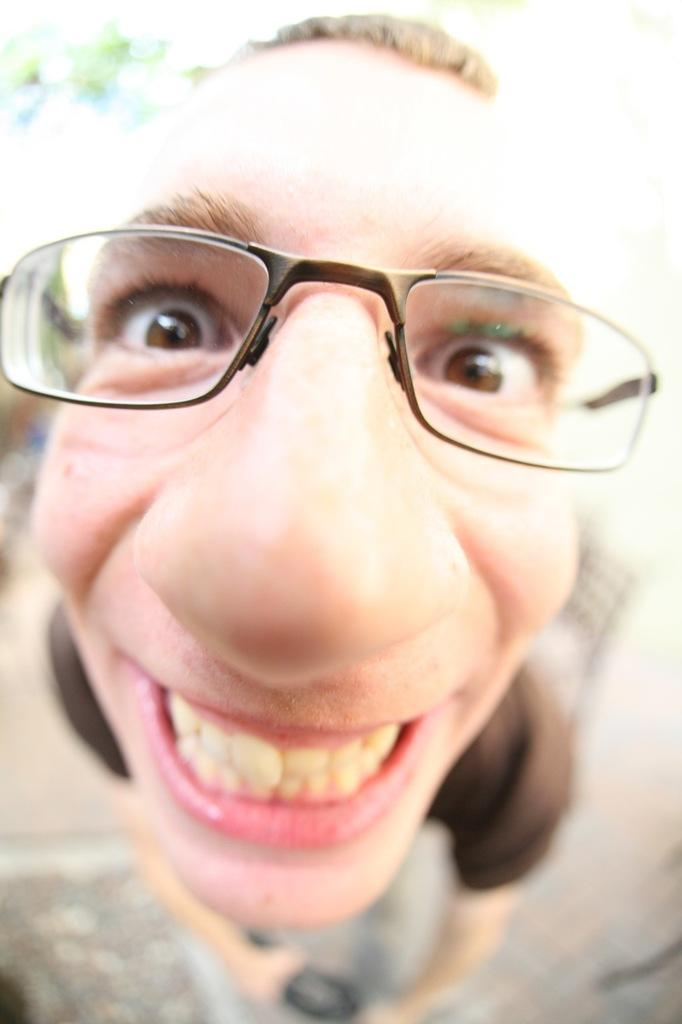What is the main subject of the image? There is a person in the image. Can you describe the person's appearance? The person is wearing spectacles. What can be observed about the background of the image? The background of the image is blurred. Can you see any wounds on the person's sock in the image? There is no sock or wound present in the image. What type of dock can be seen in the background of the image? There is no dock present in the image; the background is blurred. 